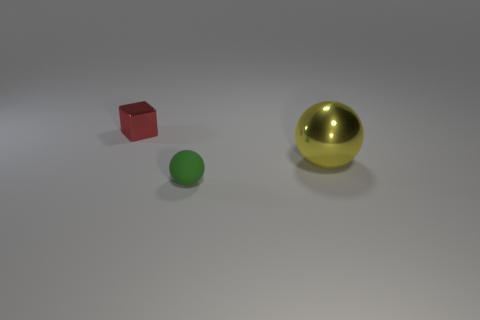Is there anything else that is the same size as the yellow metal ball?
Give a very brief answer. No. What shape is the other red thing that is the same size as the rubber thing?
Offer a very short reply. Cube. There is a tiny shiny block; are there any green matte balls behind it?
Ensure brevity in your answer.  No. Do the block and the rubber ball have the same size?
Your answer should be compact. Yes. The tiny object that is on the left side of the small sphere has what shape?
Provide a succinct answer. Cube. Is there a red cube of the same size as the green matte sphere?
Your answer should be compact. Yes. What material is the cube that is the same size as the green matte sphere?
Provide a short and direct response. Metal. What is the size of the thing that is behind the big yellow thing?
Make the answer very short. Small. What size is the green matte sphere?
Your answer should be very brief. Small. There is a shiny sphere; does it have the same size as the metallic block to the left of the small matte object?
Offer a terse response. No. 